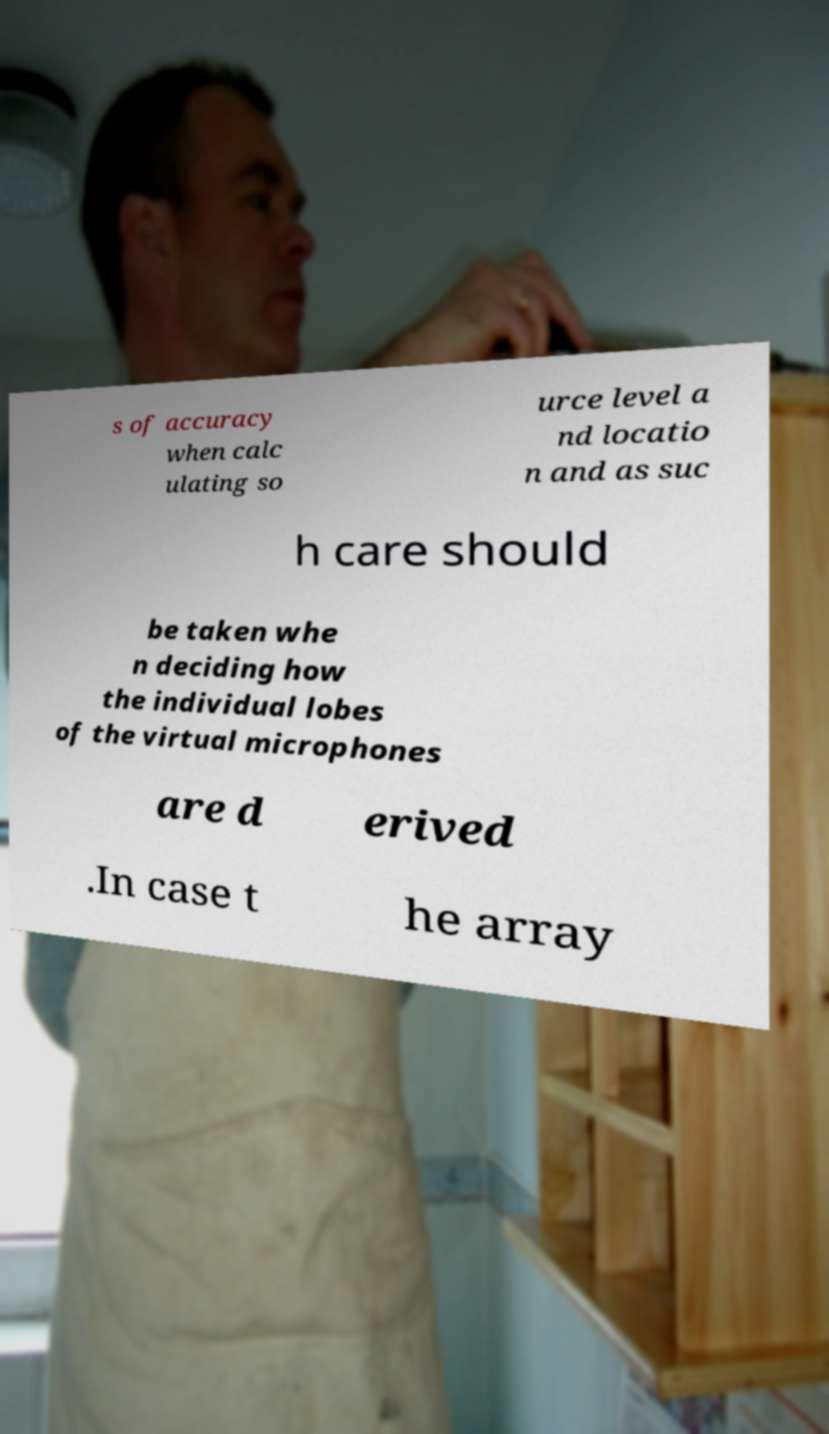Please identify and transcribe the text found in this image. s of accuracy when calc ulating so urce level a nd locatio n and as suc h care should be taken whe n deciding how the individual lobes of the virtual microphones are d erived .In case t he array 